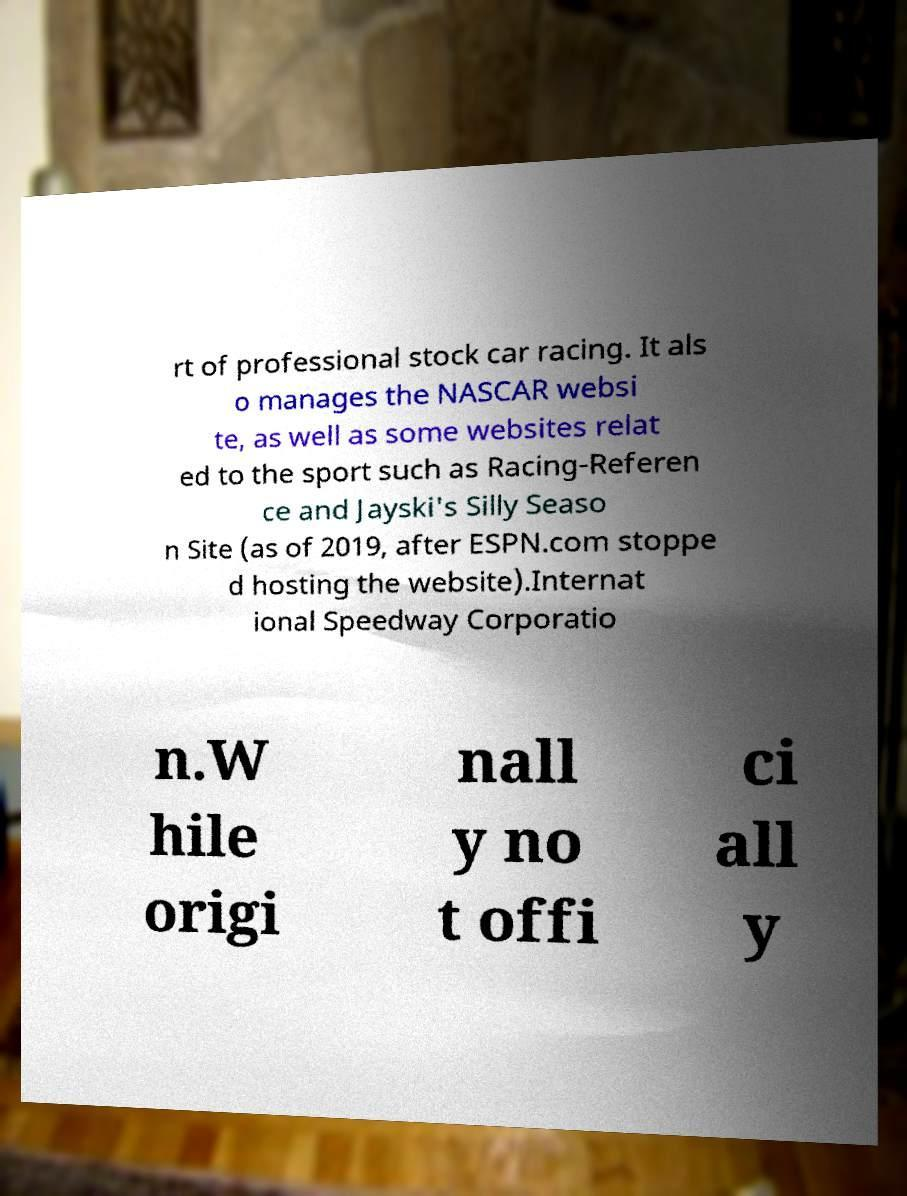Please identify and transcribe the text found in this image. rt of professional stock car racing. It als o manages the NASCAR websi te, as well as some websites relat ed to the sport such as Racing-Referen ce and Jayski's Silly Seaso n Site (as of 2019, after ESPN.com stoppe d hosting the website).Internat ional Speedway Corporatio n.W hile origi nall y no t offi ci all y 